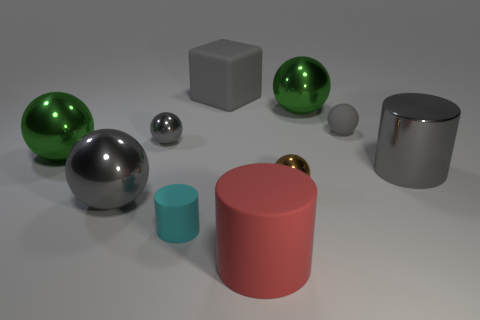Subtract all big cylinders. How many cylinders are left? 1 Subtract 1 cubes. How many cubes are left? 0 Subtract all gray spheres. How many spheres are left? 3 Subtract all red cylinders. Subtract all green spheres. How many cylinders are left? 2 Subtract all blue cylinders. How many blue cubes are left? 0 Subtract all big red rubber things. Subtract all small brown metal things. How many objects are left? 8 Add 2 large rubber cylinders. How many large rubber cylinders are left? 3 Add 2 small things. How many small things exist? 6 Subtract 1 cyan cylinders. How many objects are left? 9 Subtract all blocks. How many objects are left? 9 